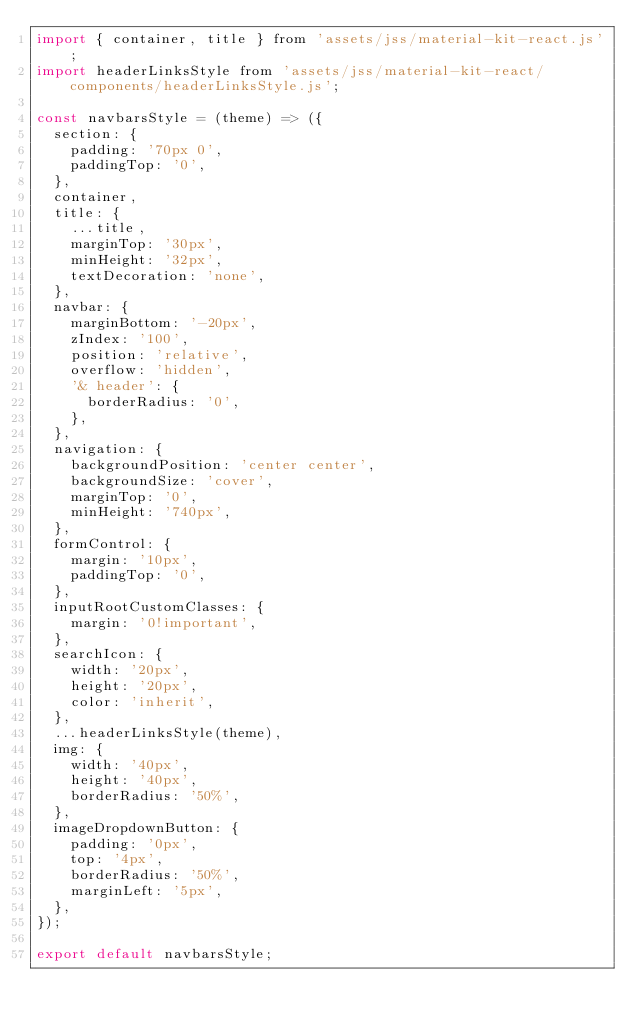Convert code to text. <code><loc_0><loc_0><loc_500><loc_500><_JavaScript_>import { container, title } from 'assets/jss/material-kit-react.js';
import headerLinksStyle from 'assets/jss/material-kit-react/components/headerLinksStyle.js';

const navbarsStyle = (theme) => ({
  section: {
    padding: '70px 0',
    paddingTop: '0',
  },
  container,
  title: {
    ...title,
    marginTop: '30px',
    minHeight: '32px',
    textDecoration: 'none',
  },
  navbar: {
    marginBottom: '-20px',
    zIndex: '100',
    position: 'relative',
    overflow: 'hidden',
    '& header': {
      borderRadius: '0',
    },
  },
  navigation: {
    backgroundPosition: 'center center',
    backgroundSize: 'cover',
    marginTop: '0',
    minHeight: '740px',
  },
  formControl: {
    margin: '10px',
    paddingTop: '0',
  },
  inputRootCustomClasses: {
    margin: '0!important',
  },
  searchIcon: {
    width: '20px',
    height: '20px',
    color: 'inherit',
  },
  ...headerLinksStyle(theme),
  img: {
    width: '40px',
    height: '40px',
    borderRadius: '50%',
  },
  imageDropdownButton: {
    padding: '0px',
    top: '4px',
    borderRadius: '50%',
    marginLeft: '5px',
  },
});

export default navbarsStyle;
</code> 